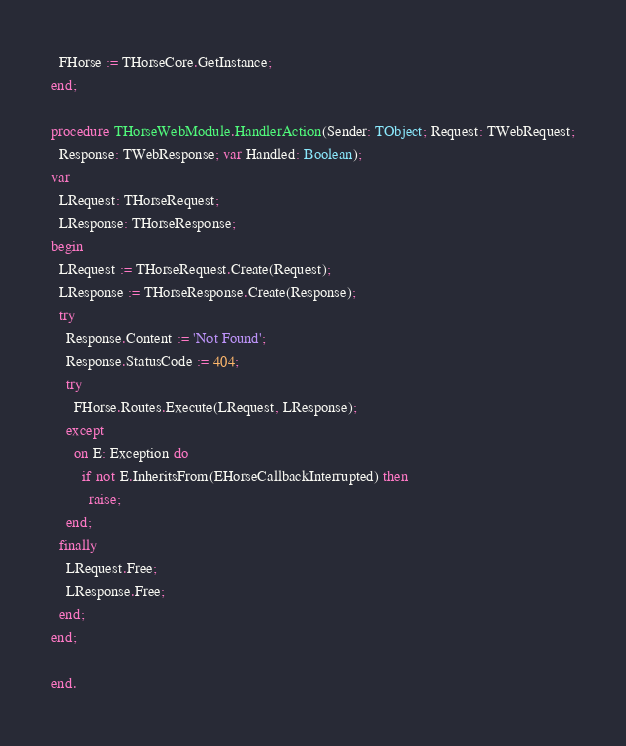Convert code to text. <code><loc_0><loc_0><loc_500><loc_500><_Pascal_>  FHorse := THorseCore.GetInstance;
end;

procedure THorseWebModule.HandlerAction(Sender: TObject; Request: TWebRequest;
  Response: TWebResponse; var Handled: Boolean);
var
  LRequest: THorseRequest;
  LResponse: THorseResponse;
begin
  LRequest := THorseRequest.Create(Request);
  LResponse := THorseResponse.Create(Response);
  try
    Response.Content := 'Not Found';
    Response.StatusCode := 404;
    try
      FHorse.Routes.Execute(LRequest, LResponse);
    except
      on E: Exception do
        if not E.InheritsFrom(EHorseCallbackInterrupted) then
          raise;
    end;
  finally
    LRequest.Free;
    LResponse.Free;
  end;
end;

end.
</code> 